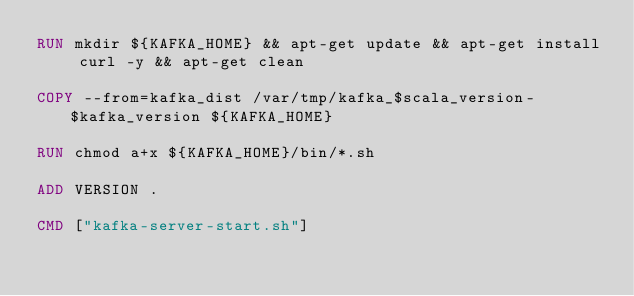Convert code to text. <code><loc_0><loc_0><loc_500><loc_500><_Dockerfile_>RUN mkdir ${KAFKA_HOME} && apt-get update && apt-get install curl -y && apt-get clean

COPY --from=kafka_dist /var/tmp/kafka_$scala_version-$kafka_version ${KAFKA_HOME}

RUN chmod a+x ${KAFKA_HOME}/bin/*.sh

ADD VERSION .

CMD ["kafka-server-start.sh"]</code> 